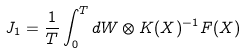<formula> <loc_0><loc_0><loc_500><loc_500>J _ { 1 } = \frac { 1 } { T } \int _ { 0 } ^ { T } d W \otimes K ( X ) ^ { - 1 } F ( X )</formula> 